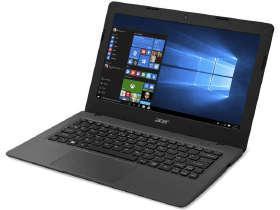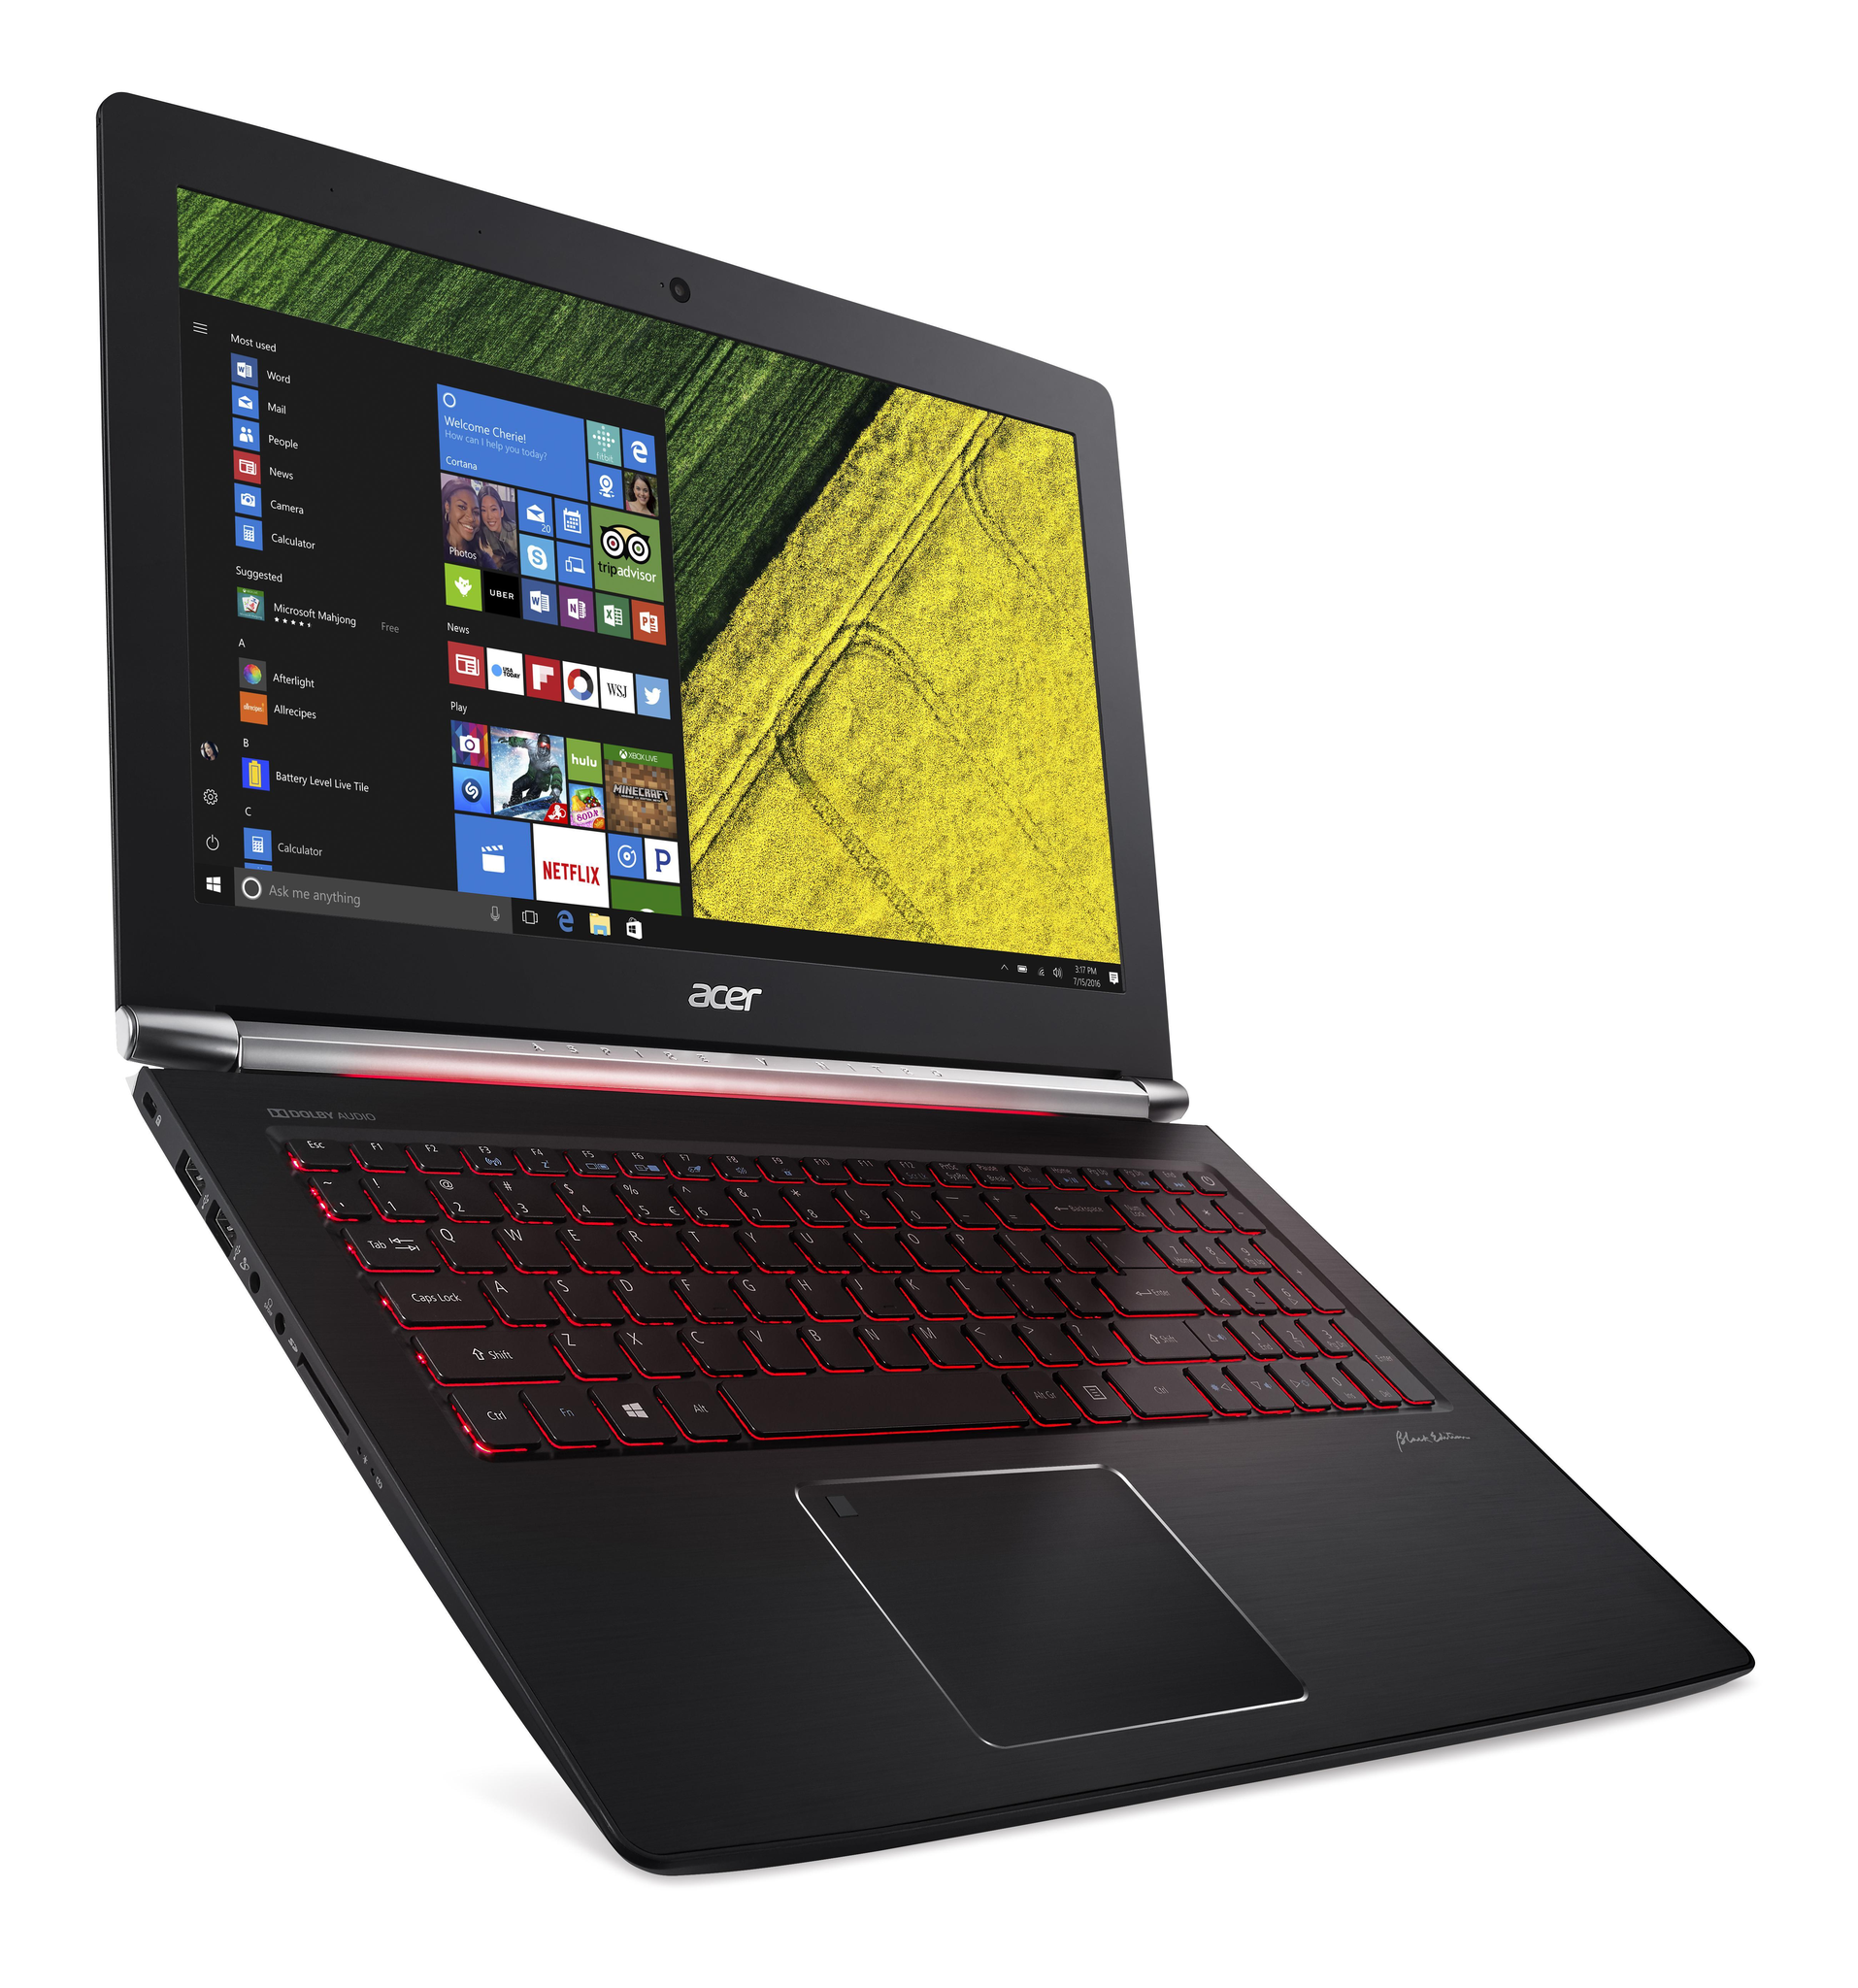The first image is the image on the left, the second image is the image on the right. Examine the images to the left and right. Is the description "All laptops are displayed on white backgrounds, and the laptop on the right shows yellow and green sections divided diagonally on the screen." accurate? Answer yes or no. Yes. The first image is the image on the left, the second image is the image on the right. For the images displayed, is the sentence "The right image features a black laptop computer with a green and yellow background visible on its screen" factually correct? Answer yes or no. Yes. 